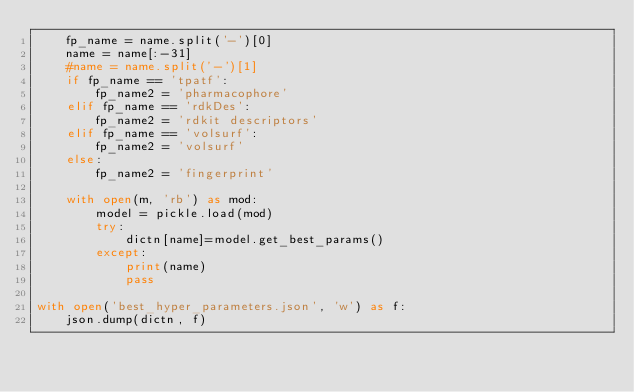<code> <loc_0><loc_0><loc_500><loc_500><_Python_>    fp_name = name.split('-')[0]
    name = name[:-31]
    #name = name.split('-')[1]
    if fp_name == 'tpatf':
        fp_name2 = 'pharmacophore'
    elif fp_name == 'rdkDes':
        fp_name2 = 'rdkit descriptors'
    elif fp_name == 'volsurf':
        fp_name2 = 'volsurf'
    else:
        fp_name2 = 'fingerprint'

    with open(m, 'rb') as mod:
        model = pickle.load(mod)
        try:
            dictn[name]=model.get_best_params()
        except:
            print(name)
            pass
            
with open('best_hyper_parameters.json', 'w') as f:
    json.dump(dictn, f)
</code> 